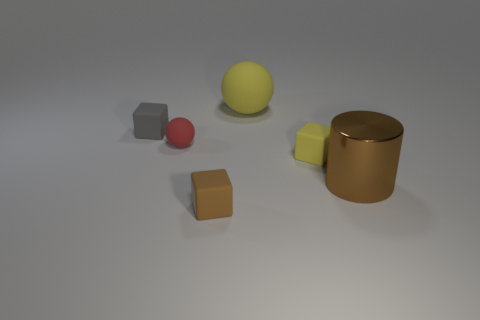Subtract all yellow cubes. How many cubes are left? 2 Add 1 brown blocks. How many objects exist? 7 Subtract all cylinders. How many objects are left? 5 Subtract all purple blocks. Subtract all green balls. How many blocks are left? 3 Add 6 small rubber spheres. How many small rubber spheres are left? 7 Add 6 tiny rubber objects. How many tiny rubber objects exist? 10 Subtract 1 brown cubes. How many objects are left? 5 Subtract all big brown metallic things. Subtract all yellow things. How many objects are left? 3 